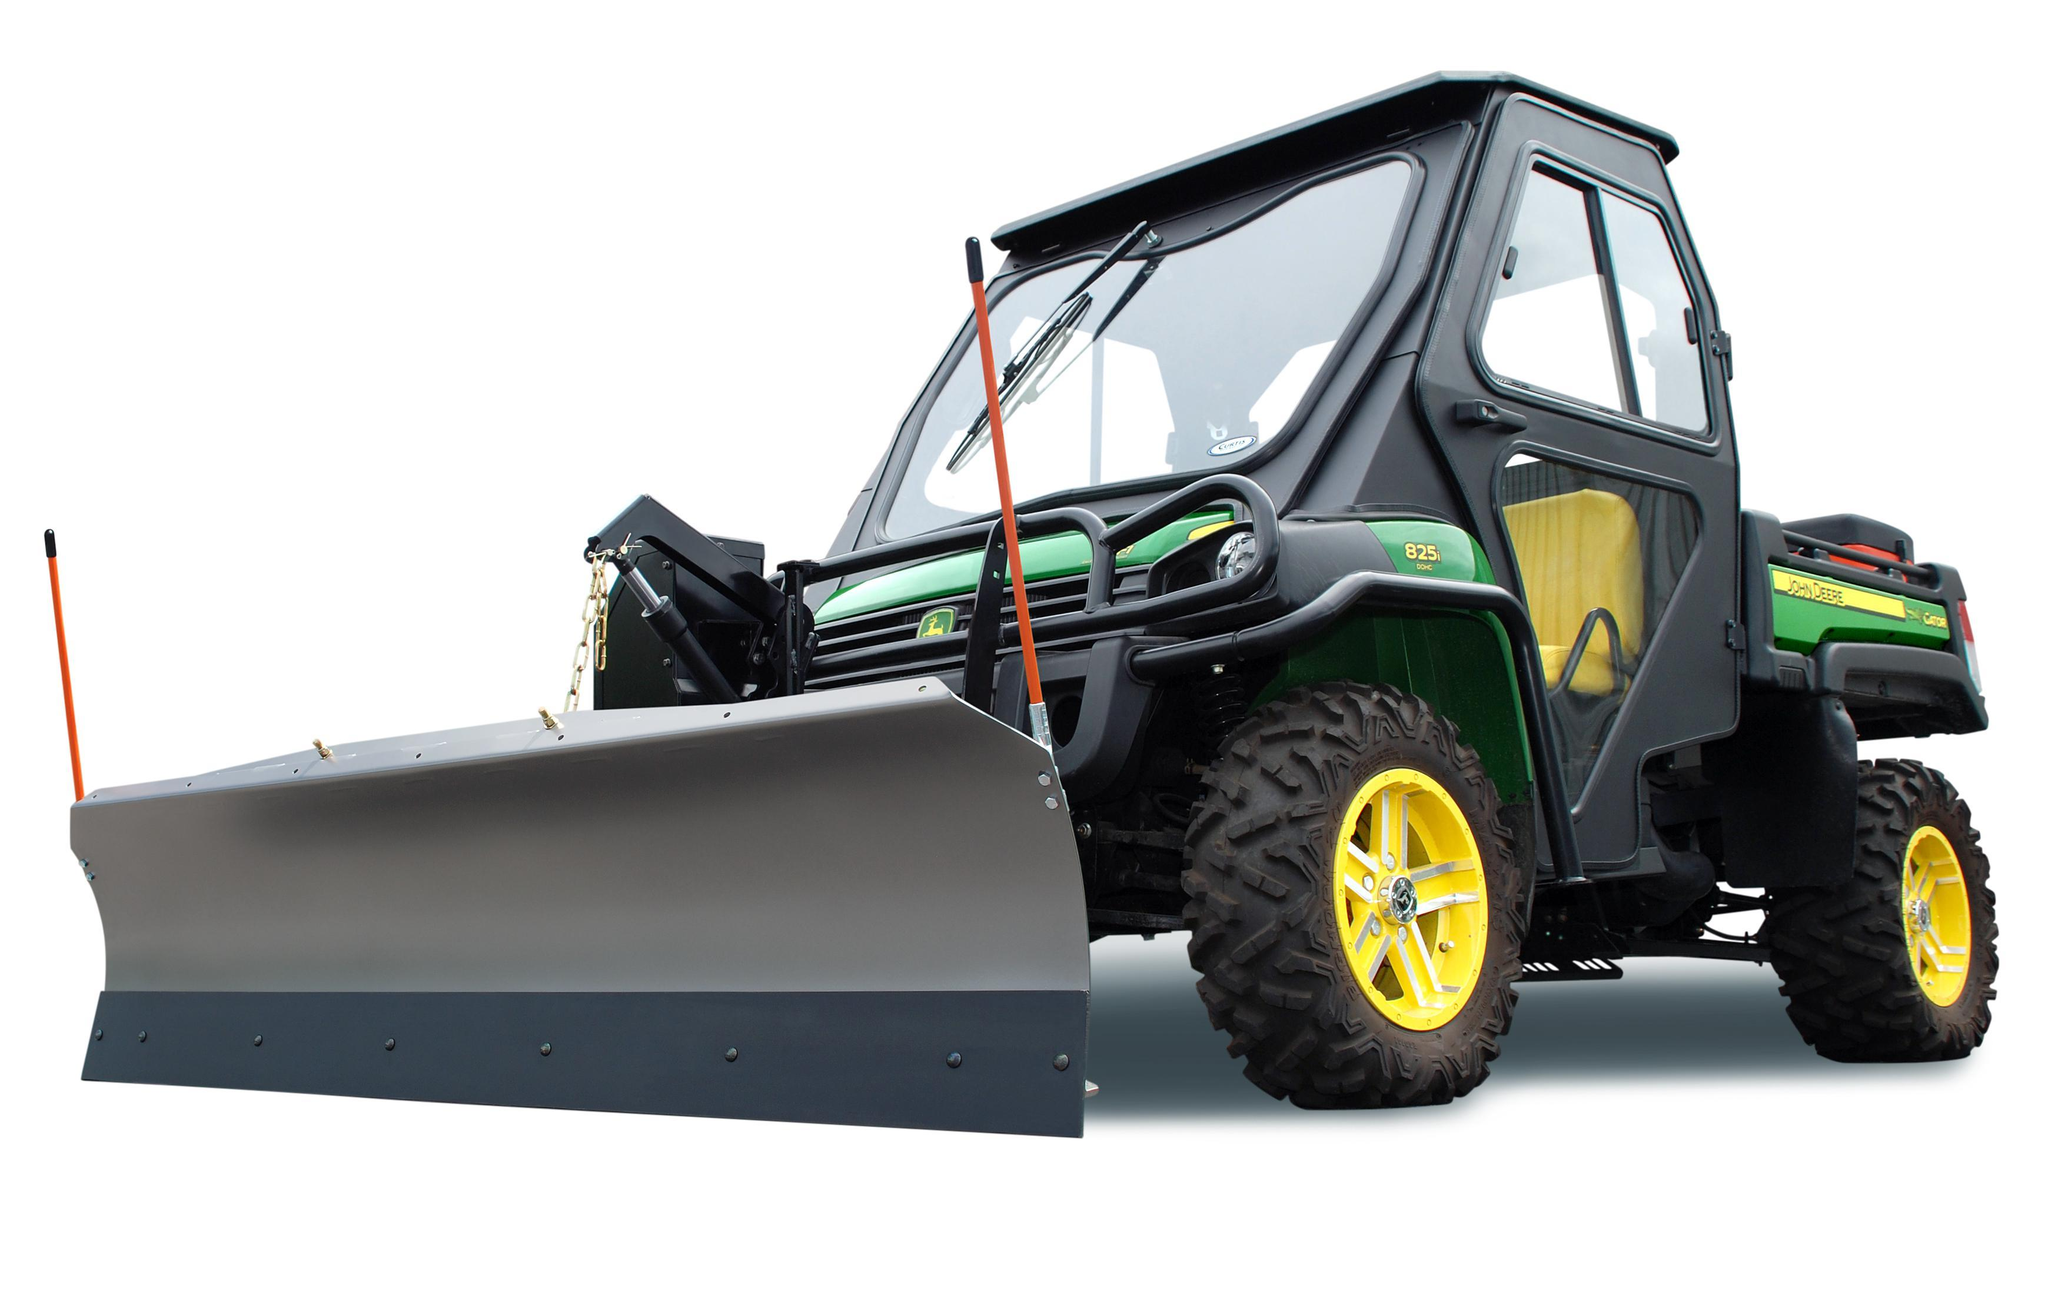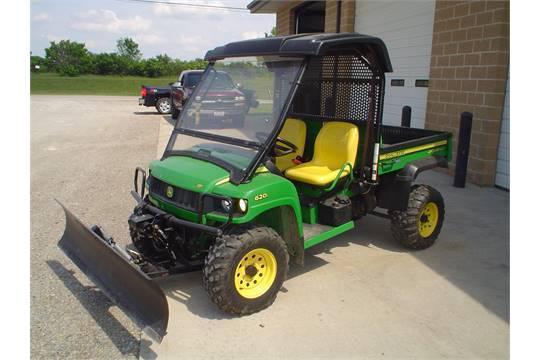The first image is the image on the left, the second image is the image on the right. Examine the images to the left and right. Is the description "One image features a vehicle with a red plow." accurate? Answer yes or no. No. 